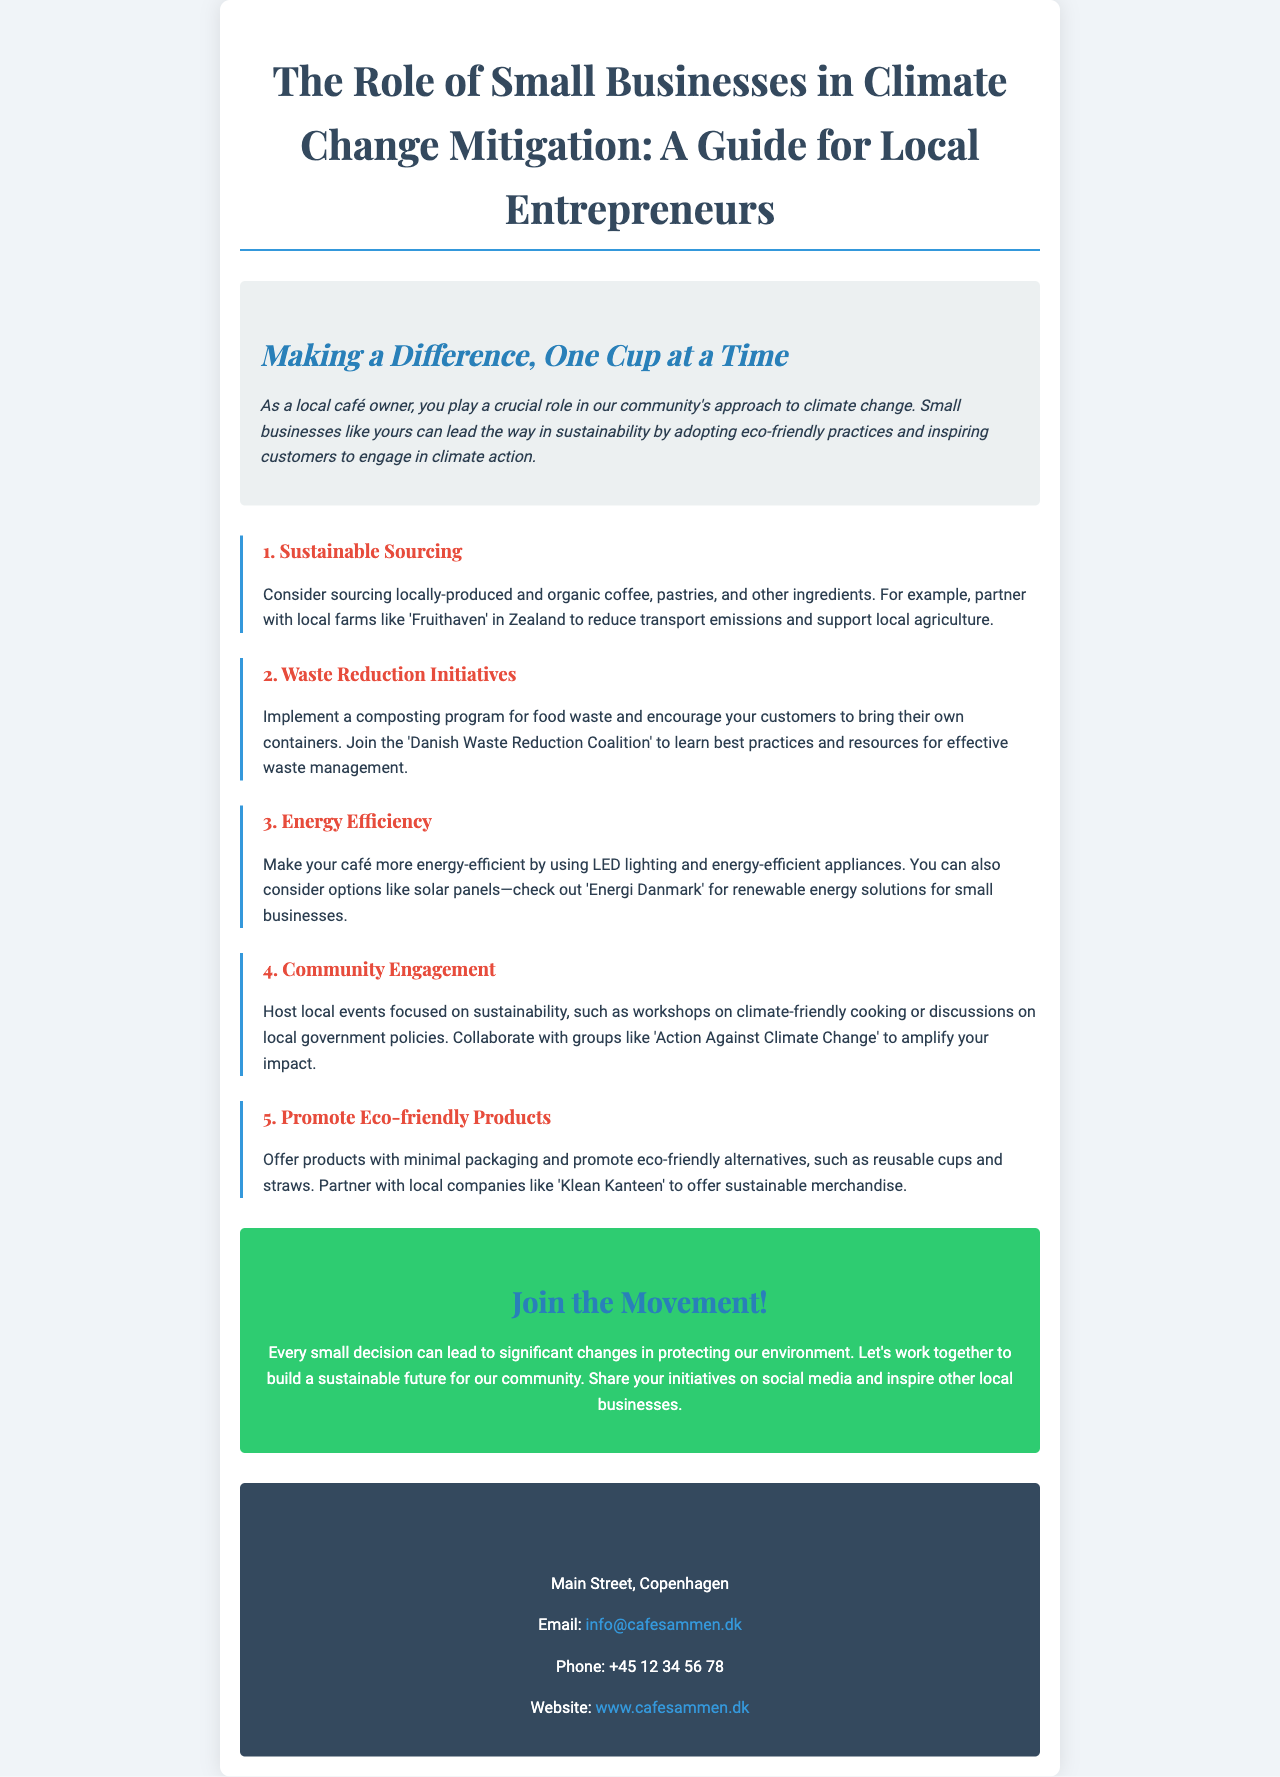What is the title of the brochure? The title is presented prominently at the top of the brochure, summarizing its main focus for local entrepreneurs.
Answer: The Role of Small Businesses in Climate Change Mitigation: A Guide for Local Entrepreneurs Who can you partner with for sustainable sourcing? The document suggests specific local farms to partner with for sourcing ingredients sustainably, which supports local agriculture.
Answer: Fruithaven What type of program can you implement for waste reduction? The brochure mentions specific initiatives that can help in managing waste effectively in the café environment.
Answer: Composting program Which energy-efficient option is recommended in the brochure? The document lists several ways to increase energy efficiency, highlighting a specific sustainable energy technology.
Answer: Solar panels What is the contact email for Café Sammen? The brochure provides a direct means of contact through an email for additional inquiries, emphasizing accessibility.
Answer: info@cafesammen.dk What color are the headings in the "Community Engagement" section? The document indicates the color coding used for different sections for visual appeal, specifically focusing on heading colors.
Answer: Red Which group can you collaborate with for community engagement? The brochure suggests a specific organization that focuses on climate action and collaboration within the community.
Answer: Action Against Climate Change What is the suggested action for local entrepreneurs to share their initiatives? The brochure encourages a specific form of communication to inspire other businesses, creating a connected community.
Answer: Social media 